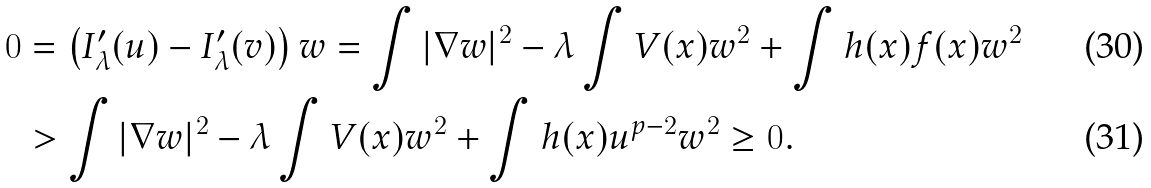<formula> <loc_0><loc_0><loc_500><loc_500>0 & = \left ( I ^ { \prime } _ { \lambda } ( u ) - I ^ { \prime } _ { \lambda } ( v ) \right ) w = \int | \nabla w | ^ { 2 } - \lambda \int V ( x ) w ^ { 2 } + \int h ( x ) f ( x ) w ^ { 2 } \\ & > \int | \nabla w | ^ { 2 } - \lambda \int V ( x ) w ^ { 2 } + \int h ( x ) u ^ { p - 2 } w ^ { 2 } \geq 0 .</formula> 